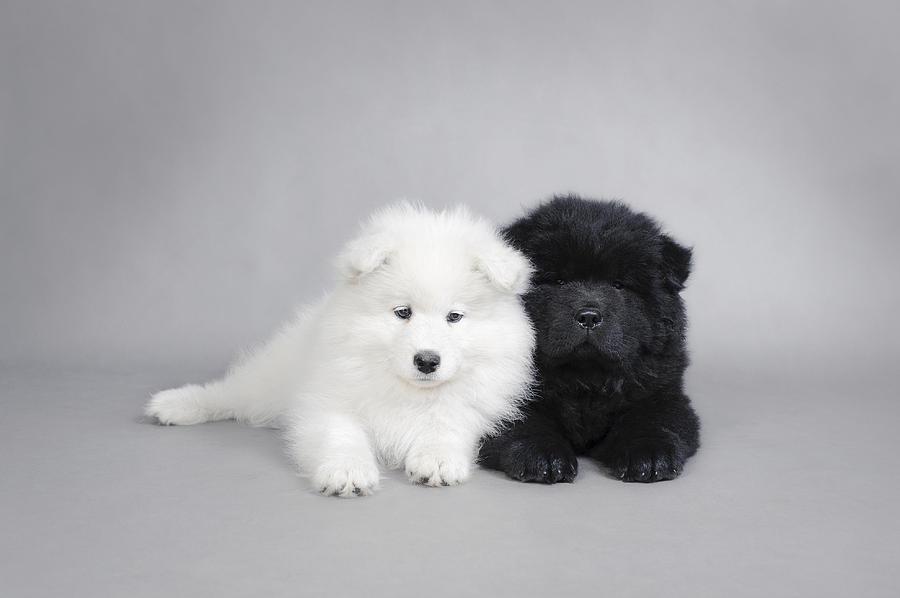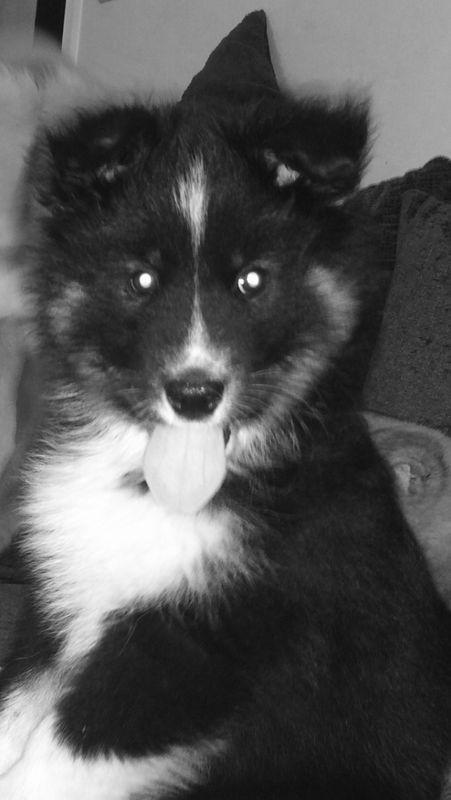The first image is the image on the left, the second image is the image on the right. Analyze the images presented: Is the assertion "One of the images features two dogs side by side." valid? Answer yes or no. Yes. The first image is the image on the left, the second image is the image on the right. For the images shown, is this caption "Only white dogs are shown and no image contains more than one dog, and one image shows a white non-standing dog with front paws forward." true? Answer yes or no. No. 